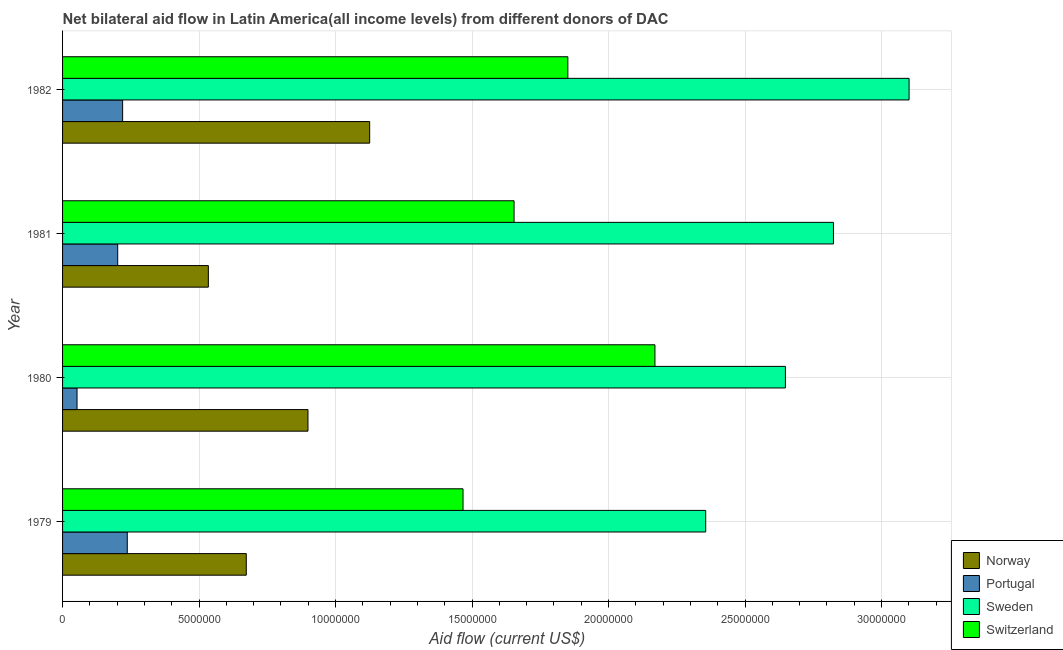Are the number of bars on each tick of the Y-axis equal?
Offer a terse response. Yes. How many bars are there on the 4th tick from the top?
Offer a terse response. 4. How many bars are there on the 2nd tick from the bottom?
Offer a very short reply. 4. What is the label of the 1st group of bars from the top?
Offer a terse response. 1982. In how many cases, is the number of bars for a given year not equal to the number of legend labels?
Provide a succinct answer. 0. What is the amount of aid given by portugal in 1979?
Keep it short and to the point. 2.37e+06. Across all years, what is the maximum amount of aid given by portugal?
Your response must be concise. 2.37e+06. Across all years, what is the minimum amount of aid given by norway?
Make the answer very short. 5.34e+06. In which year was the amount of aid given by sweden maximum?
Provide a succinct answer. 1982. In which year was the amount of aid given by portugal minimum?
Provide a succinct answer. 1980. What is the total amount of aid given by switzerland in the graph?
Provide a short and direct response. 7.14e+07. What is the difference between the amount of aid given by switzerland in 1981 and that in 1982?
Provide a short and direct response. -1.97e+06. What is the difference between the amount of aid given by portugal in 1982 and the amount of aid given by sweden in 1981?
Your answer should be very brief. -2.60e+07. What is the average amount of aid given by switzerland per year?
Keep it short and to the point. 1.79e+07. In the year 1980, what is the difference between the amount of aid given by sweden and amount of aid given by switzerland?
Your answer should be compact. 4.78e+06. In how many years, is the amount of aid given by sweden greater than 9000000 US$?
Provide a succinct answer. 4. What is the ratio of the amount of aid given by sweden in 1980 to that in 1981?
Your answer should be very brief. 0.94. Is the difference between the amount of aid given by norway in 1981 and 1982 greater than the difference between the amount of aid given by switzerland in 1981 and 1982?
Your response must be concise. No. What is the difference between the highest and the lowest amount of aid given by sweden?
Keep it short and to the point. 7.45e+06. In how many years, is the amount of aid given by portugal greater than the average amount of aid given by portugal taken over all years?
Provide a succinct answer. 3. Is the sum of the amount of aid given by sweden in 1979 and 1980 greater than the maximum amount of aid given by switzerland across all years?
Provide a succinct answer. Yes. What does the 2nd bar from the top in 1981 represents?
Ensure brevity in your answer.  Sweden. Is it the case that in every year, the sum of the amount of aid given by norway and amount of aid given by portugal is greater than the amount of aid given by sweden?
Provide a succinct answer. No. How many bars are there?
Give a very brief answer. 16. Are all the bars in the graph horizontal?
Make the answer very short. Yes. Are the values on the major ticks of X-axis written in scientific E-notation?
Make the answer very short. No. Where does the legend appear in the graph?
Your answer should be very brief. Bottom right. What is the title of the graph?
Provide a short and direct response. Net bilateral aid flow in Latin America(all income levels) from different donors of DAC. Does "Terrestrial protected areas" appear as one of the legend labels in the graph?
Provide a short and direct response. No. What is the Aid flow (current US$) of Norway in 1979?
Provide a short and direct response. 6.73e+06. What is the Aid flow (current US$) of Portugal in 1979?
Provide a short and direct response. 2.37e+06. What is the Aid flow (current US$) in Sweden in 1979?
Keep it short and to the point. 2.36e+07. What is the Aid flow (current US$) of Switzerland in 1979?
Your answer should be compact. 1.47e+07. What is the Aid flow (current US$) in Norway in 1980?
Ensure brevity in your answer.  8.99e+06. What is the Aid flow (current US$) in Portugal in 1980?
Make the answer very short. 5.30e+05. What is the Aid flow (current US$) of Sweden in 1980?
Provide a short and direct response. 2.65e+07. What is the Aid flow (current US$) in Switzerland in 1980?
Keep it short and to the point. 2.17e+07. What is the Aid flow (current US$) of Norway in 1981?
Make the answer very short. 5.34e+06. What is the Aid flow (current US$) of Portugal in 1981?
Give a very brief answer. 2.02e+06. What is the Aid flow (current US$) in Sweden in 1981?
Your response must be concise. 2.82e+07. What is the Aid flow (current US$) of Switzerland in 1981?
Keep it short and to the point. 1.65e+07. What is the Aid flow (current US$) of Norway in 1982?
Your answer should be very brief. 1.12e+07. What is the Aid flow (current US$) of Portugal in 1982?
Your response must be concise. 2.20e+06. What is the Aid flow (current US$) of Sweden in 1982?
Offer a very short reply. 3.10e+07. What is the Aid flow (current US$) of Switzerland in 1982?
Your response must be concise. 1.85e+07. Across all years, what is the maximum Aid flow (current US$) of Norway?
Make the answer very short. 1.12e+07. Across all years, what is the maximum Aid flow (current US$) in Portugal?
Provide a short and direct response. 2.37e+06. Across all years, what is the maximum Aid flow (current US$) in Sweden?
Offer a very short reply. 3.10e+07. Across all years, what is the maximum Aid flow (current US$) in Switzerland?
Ensure brevity in your answer.  2.17e+07. Across all years, what is the minimum Aid flow (current US$) in Norway?
Offer a very short reply. 5.34e+06. Across all years, what is the minimum Aid flow (current US$) of Portugal?
Give a very brief answer. 5.30e+05. Across all years, what is the minimum Aid flow (current US$) of Sweden?
Make the answer very short. 2.36e+07. Across all years, what is the minimum Aid flow (current US$) in Switzerland?
Offer a terse response. 1.47e+07. What is the total Aid flow (current US$) in Norway in the graph?
Give a very brief answer. 3.23e+07. What is the total Aid flow (current US$) of Portugal in the graph?
Provide a succinct answer. 7.12e+06. What is the total Aid flow (current US$) of Sweden in the graph?
Keep it short and to the point. 1.09e+08. What is the total Aid flow (current US$) in Switzerland in the graph?
Offer a very short reply. 7.14e+07. What is the difference between the Aid flow (current US$) of Norway in 1979 and that in 1980?
Offer a very short reply. -2.26e+06. What is the difference between the Aid flow (current US$) of Portugal in 1979 and that in 1980?
Make the answer very short. 1.84e+06. What is the difference between the Aid flow (current US$) in Sweden in 1979 and that in 1980?
Ensure brevity in your answer.  -2.92e+06. What is the difference between the Aid flow (current US$) of Switzerland in 1979 and that in 1980?
Make the answer very short. -7.03e+06. What is the difference between the Aid flow (current US$) in Norway in 1979 and that in 1981?
Provide a short and direct response. 1.39e+06. What is the difference between the Aid flow (current US$) in Sweden in 1979 and that in 1981?
Provide a short and direct response. -4.68e+06. What is the difference between the Aid flow (current US$) of Switzerland in 1979 and that in 1981?
Provide a short and direct response. -1.87e+06. What is the difference between the Aid flow (current US$) of Norway in 1979 and that in 1982?
Ensure brevity in your answer.  -4.52e+06. What is the difference between the Aid flow (current US$) in Sweden in 1979 and that in 1982?
Provide a short and direct response. -7.45e+06. What is the difference between the Aid flow (current US$) of Switzerland in 1979 and that in 1982?
Your response must be concise. -3.84e+06. What is the difference between the Aid flow (current US$) in Norway in 1980 and that in 1981?
Your response must be concise. 3.65e+06. What is the difference between the Aid flow (current US$) in Portugal in 1980 and that in 1981?
Your response must be concise. -1.49e+06. What is the difference between the Aid flow (current US$) of Sweden in 1980 and that in 1981?
Your answer should be compact. -1.76e+06. What is the difference between the Aid flow (current US$) in Switzerland in 1980 and that in 1981?
Give a very brief answer. 5.16e+06. What is the difference between the Aid flow (current US$) of Norway in 1980 and that in 1982?
Ensure brevity in your answer.  -2.26e+06. What is the difference between the Aid flow (current US$) in Portugal in 1980 and that in 1982?
Your answer should be very brief. -1.67e+06. What is the difference between the Aid flow (current US$) of Sweden in 1980 and that in 1982?
Give a very brief answer. -4.53e+06. What is the difference between the Aid flow (current US$) of Switzerland in 1980 and that in 1982?
Offer a very short reply. 3.19e+06. What is the difference between the Aid flow (current US$) of Norway in 1981 and that in 1982?
Provide a short and direct response. -5.91e+06. What is the difference between the Aid flow (current US$) of Sweden in 1981 and that in 1982?
Provide a succinct answer. -2.77e+06. What is the difference between the Aid flow (current US$) in Switzerland in 1981 and that in 1982?
Offer a very short reply. -1.97e+06. What is the difference between the Aid flow (current US$) in Norway in 1979 and the Aid flow (current US$) in Portugal in 1980?
Provide a short and direct response. 6.20e+06. What is the difference between the Aid flow (current US$) in Norway in 1979 and the Aid flow (current US$) in Sweden in 1980?
Keep it short and to the point. -1.98e+07. What is the difference between the Aid flow (current US$) in Norway in 1979 and the Aid flow (current US$) in Switzerland in 1980?
Give a very brief answer. -1.50e+07. What is the difference between the Aid flow (current US$) in Portugal in 1979 and the Aid flow (current US$) in Sweden in 1980?
Your response must be concise. -2.41e+07. What is the difference between the Aid flow (current US$) of Portugal in 1979 and the Aid flow (current US$) of Switzerland in 1980?
Offer a very short reply. -1.93e+07. What is the difference between the Aid flow (current US$) of Sweden in 1979 and the Aid flow (current US$) of Switzerland in 1980?
Your answer should be very brief. 1.86e+06. What is the difference between the Aid flow (current US$) in Norway in 1979 and the Aid flow (current US$) in Portugal in 1981?
Your response must be concise. 4.71e+06. What is the difference between the Aid flow (current US$) of Norway in 1979 and the Aid flow (current US$) of Sweden in 1981?
Your answer should be very brief. -2.15e+07. What is the difference between the Aid flow (current US$) of Norway in 1979 and the Aid flow (current US$) of Switzerland in 1981?
Provide a short and direct response. -9.81e+06. What is the difference between the Aid flow (current US$) in Portugal in 1979 and the Aid flow (current US$) in Sweden in 1981?
Offer a terse response. -2.59e+07. What is the difference between the Aid flow (current US$) in Portugal in 1979 and the Aid flow (current US$) in Switzerland in 1981?
Keep it short and to the point. -1.42e+07. What is the difference between the Aid flow (current US$) of Sweden in 1979 and the Aid flow (current US$) of Switzerland in 1981?
Your answer should be compact. 7.02e+06. What is the difference between the Aid flow (current US$) of Norway in 1979 and the Aid flow (current US$) of Portugal in 1982?
Offer a very short reply. 4.53e+06. What is the difference between the Aid flow (current US$) in Norway in 1979 and the Aid flow (current US$) in Sweden in 1982?
Offer a very short reply. -2.43e+07. What is the difference between the Aid flow (current US$) of Norway in 1979 and the Aid flow (current US$) of Switzerland in 1982?
Offer a terse response. -1.18e+07. What is the difference between the Aid flow (current US$) of Portugal in 1979 and the Aid flow (current US$) of Sweden in 1982?
Your answer should be compact. -2.86e+07. What is the difference between the Aid flow (current US$) in Portugal in 1979 and the Aid flow (current US$) in Switzerland in 1982?
Your answer should be compact. -1.61e+07. What is the difference between the Aid flow (current US$) of Sweden in 1979 and the Aid flow (current US$) of Switzerland in 1982?
Your response must be concise. 5.05e+06. What is the difference between the Aid flow (current US$) in Norway in 1980 and the Aid flow (current US$) in Portugal in 1981?
Ensure brevity in your answer.  6.97e+06. What is the difference between the Aid flow (current US$) in Norway in 1980 and the Aid flow (current US$) in Sweden in 1981?
Offer a terse response. -1.92e+07. What is the difference between the Aid flow (current US$) in Norway in 1980 and the Aid flow (current US$) in Switzerland in 1981?
Keep it short and to the point. -7.55e+06. What is the difference between the Aid flow (current US$) in Portugal in 1980 and the Aid flow (current US$) in Sweden in 1981?
Provide a short and direct response. -2.77e+07. What is the difference between the Aid flow (current US$) of Portugal in 1980 and the Aid flow (current US$) of Switzerland in 1981?
Your answer should be very brief. -1.60e+07. What is the difference between the Aid flow (current US$) in Sweden in 1980 and the Aid flow (current US$) in Switzerland in 1981?
Your answer should be very brief. 9.94e+06. What is the difference between the Aid flow (current US$) in Norway in 1980 and the Aid flow (current US$) in Portugal in 1982?
Your answer should be very brief. 6.79e+06. What is the difference between the Aid flow (current US$) of Norway in 1980 and the Aid flow (current US$) of Sweden in 1982?
Give a very brief answer. -2.20e+07. What is the difference between the Aid flow (current US$) of Norway in 1980 and the Aid flow (current US$) of Switzerland in 1982?
Ensure brevity in your answer.  -9.52e+06. What is the difference between the Aid flow (current US$) in Portugal in 1980 and the Aid flow (current US$) in Sweden in 1982?
Your answer should be very brief. -3.05e+07. What is the difference between the Aid flow (current US$) in Portugal in 1980 and the Aid flow (current US$) in Switzerland in 1982?
Make the answer very short. -1.80e+07. What is the difference between the Aid flow (current US$) in Sweden in 1980 and the Aid flow (current US$) in Switzerland in 1982?
Your answer should be very brief. 7.97e+06. What is the difference between the Aid flow (current US$) of Norway in 1981 and the Aid flow (current US$) of Portugal in 1982?
Your answer should be compact. 3.14e+06. What is the difference between the Aid flow (current US$) of Norway in 1981 and the Aid flow (current US$) of Sweden in 1982?
Provide a succinct answer. -2.57e+07. What is the difference between the Aid flow (current US$) of Norway in 1981 and the Aid flow (current US$) of Switzerland in 1982?
Provide a short and direct response. -1.32e+07. What is the difference between the Aid flow (current US$) of Portugal in 1981 and the Aid flow (current US$) of Sweden in 1982?
Make the answer very short. -2.90e+07. What is the difference between the Aid flow (current US$) in Portugal in 1981 and the Aid flow (current US$) in Switzerland in 1982?
Keep it short and to the point. -1.65e+07. What is the difference between the Aid flow (current US$) in Sweden in 1981 and the Aid flow (current US$) in Switzerland in 1982?
Your answer should be compact. 9.73e+06. What is the average Aid flow (current US$) in Norway per year?
Ensure brevity in your answer.  8.08e+06. What is the average Aid flow (current US$) of Portugal per year?
Offer a very short reply. 1.78e+06. What is the average Aid flow (current US$) of Sweden per year?
Provide a short and direct response. 2.73e+07. What is the average Aid flow (current US$) in Switzerland per year?
Keep it short and to the point. 1.79e+07. In the year 1979, what is the difference between the Aid flow (current US$) in Norway and Aid flow (current US$) in Portugal?
Provide a succinct answer. 4.36e+06. In the year 1979, what is the difference between the Aid flow (current US$) in Norway and Aid flow (current US$) in Sweden?
Offer a terse response. -1.68e+07. In the year 1979, what is the difference between the Aid flow (current US$) in Norway and Aid flow (current US$) in Switzerland?
Your response must be concise. -7.94e+06. In the year 1979, what is the difference between the Aid flow (current US$) in Portugal and Aid flow (current US$) in Sweden?
Your response must be concise. -2.12e+07. In the year 1979, what is the difference between the Aid flow (current US$) of Portugal and Aid flow (current US$) of Switzerland?
Your response must be concise. -1.23e+07. In the year 1979, what is the difference between the Aid flow (current US$) of Sweden and Aid flow (current US$) of Switzerland?
Offer a very short reply. 8.89e+06. In the year 1980, what is the difference between the Aid flow (current US$) of Norway and Aid flow (current US$) of Portugal?
Offer a very short reply. 8.46e+06. In the year 1980, what is the difference between the Aid flow (current US$) in Norway and Aid flow (current US$) in Sweden?
Keep it short and to the point. -1.75e+07. In the year 1980, what is the difference between the Aid flow (current US$) of Norway and Aid flow (current US$) of Switzerland?
Keep it short and to the point. -1.27e+07. In the year 1980, what is the difference between the Aid flow (current US$) in Portugal and Aid flow (current US$) in Sweden?
Keep it short and to the point. -2.60e+07. In the year 1980, what is the difference between the Aid flow (current US$) in Portugal and Aid flow (current US$) in Switzerland?
Ensure brevity in your answer.  -2.12e+07. In the year 1980, what is the difference between the Aid flow (current US$) in Sweden and Aid flow (current US$) in Switzerland?
Your response must be concise. 4.78e+06. In the year 1981, what is the difference between the Aid flow (current US$) in Norway and Aid flow (current US$) in Portugal?
Your response must be concise. 3.32e+06. In the year 1981, what is the difference between the Aid flow (current US$) in Norway and Aid flow (current US$) in Sweden?
Offer a very short reply. -2.29e+07. In the year 1981, what is the difference between the Aid flow (current US$) in Norway and Aid flow (current US$) in Switzerland?
Provide a short and direct response. -1.12e+07. In the year 1981, what is the difference between the Aid flow (current US$) of Portugal and Aid flow (current US$) of Sweden?
Make the answer very short. -2.62e+07. In the year 1981, what is the difference between the Aid flow (current US$) in Portugal and Aid flow (current US$) in Switzerland?
Your answer should be compact. -1.45e+07. In the year 1981, what is the difference between the Aid flow (current US$) in Sweden and Aid flow (current US$) in Switzerland?
Offer a very short reply. 1.17e+07. In the year 1982, what is the difference between the Aid flow (current US$) in Norway and Aid flow (current US$) in Portugal?
Provide a succinct answer. 9.05e+06. In the year 1982, what is the difference between the Aid flow (current US$) in Norway and Aid flow (current US$) in Sweden?
Your answer should be compact. -1.98e+07. In the year 1982, what is the difference between the Aid flow (current US$) of Norway and Aid flow (current US$) of Switzerland?
Ensure brevity in your answer.  -7.26e+06. In the year 1982, what is the difference between the Aid flow (current US$) of Portugal and Aid flow (current US$) of Sweden?
Provide a short and direct response. -2.88e+07. In the year 1982, what is the difference between the Aid flow (current US$) of Portugal and Aid flow (current US$) of Switzerland?
Your answer should be compact. -1.63e+07. In the year 1982, what is the difference between the Aid flow (current US$) in Sweden and Aid flow (current US$) in Switzerland?
Keep it short and to the point. 1.25e+07. What is the ratio of the Aid flow (current US$) in Norway in 1979 to that in 1980?
Provide a short and direct response. 0.75. What is the ratio of the Aid flow (current US$) in Portugal in 1979 to that in 1980?
Give a very brief answer. 4.47. What is the ratio of the Aid flow (current US$) of Sweden in 1979 to that in 1980?
Your answer should be compact. 0.89. What is the ratio of the Aid flow (current US$) of Switzerland in 1979 to that in 1980?
Provide a succinct answer. 0.68. What is the ratio of the Aid flow (current US$) of Norway in 1979 to that in 1981?
Offer a very short reply. 1.26. What is the ratio of the Aid flow (current US$) in Portugal in 1979 to that in 1981?
Provide a succinct answer. 1.17. What is the ratio of the Aid flow (current US$) in Sweden in 1979 to that in 1981?
Provide a short and direct response. 0.83. What is the ratio of the Aid flow (current US$) in Switzerland in 1979 to that in 1981?
Ensure brevity in your answer.  0.89. What is the ratio of the Aid flow (current US$) of Norway in 1979 to that in 1982?
Ensure brevity in your answer.  0.6. What is the ratio of the Aid flow (current US$) in Portugal in 1979 to that in 1982?
Ensure brevity in your answer.  1.08. What is the ratio of the Aid flow (current US$) in Sweden in 1979 to that in 1982?
Your answer should be compact. 0.76. What is the ratio of the Aid flow (current US$) of Switzerland in 1979 to that in 1982?
Ensure brevity in your answer.  0.79. What is the ratio of the Aid flow (current US$) of Norway in 1980 to that in 1981?
Give a very brief answer. 1.68. What is the ratio of the Aid flow (current US$) in Portugal in 1980 to that in 1981?
Offer a very short reply. 0.26. What is the ratio of the Aid flow (current US$) in Sweden in 1980 to that in 1981?
Give a very brief answer. 0.94. What is the ratio of the Aid flow (current US$) of Switzerland in 1980 to that in 1981?
Keep it short and to the point. 1.31. What is the ratio of the Aid flow (current US$) in Norway in 1980 to that in 1982?
Your answer should be compact. 0.8. What is the ratio of the Aid flow (current US$) of Portugal in 1980 to that in 1982?
Your answer should be compact. 0.24. What is the ratio of the Aid flow (current US$) in Sweden in 1980 to that in 1982?
Keep it short and to the point. 0.85. What is the ratio of the Aid flow (current US$) in Switzerland in 1980 to that in 1982?
Your response must be concise. 1.17. What is the ratio of the Aid flow (current US$) of Norway in 1981 to that in 1982?
Make the answer very short. 0.47. What is the ratio of the Aid flow (current US$) in Portugal in 1981 to that in 1982?
Provide a short and direct response. 0.92. What is the ratio of the Aid flow (current US$) in Sweden in 1981 to that in 1982?
Ensure brevity in your answer.  0.91. What is the ratio of the Aid flow (current US$) in Switzerland in 1981 to that in 1982?
Your answer should be compact. 0.89. What is the difference between the highest and the second highest Aid flow (current US$) of Norway?
Your answer should be very brief. 2.26e+06. What is the difference between the highest and the second highest Aid flow (current US$) of Sweden?
Offer a terse response. 2.77e+06. What is the difference between the highest and the second highest Aid flow (current US$) in Switzerland?
Your answer should be very brief. 3.19e+06. What is the difference between the highest and the lowest Aid flow (current US$) in Norway?
Your response must be concise. 5.91e+06. What is the difference between the highest and the lowest Aid flow (current US$) in Portugal?
Your answer should be compact. 1.84e+06. What is the difference between the highest and the lowest Aid flow (current US$) in Sweden?
Offer a terse response. 7.45e+06. What is the difference between the highest and the lowest Aid flow (current US$) in Switzerland?
Ensure brevity in your answer.  7.03e+06. 